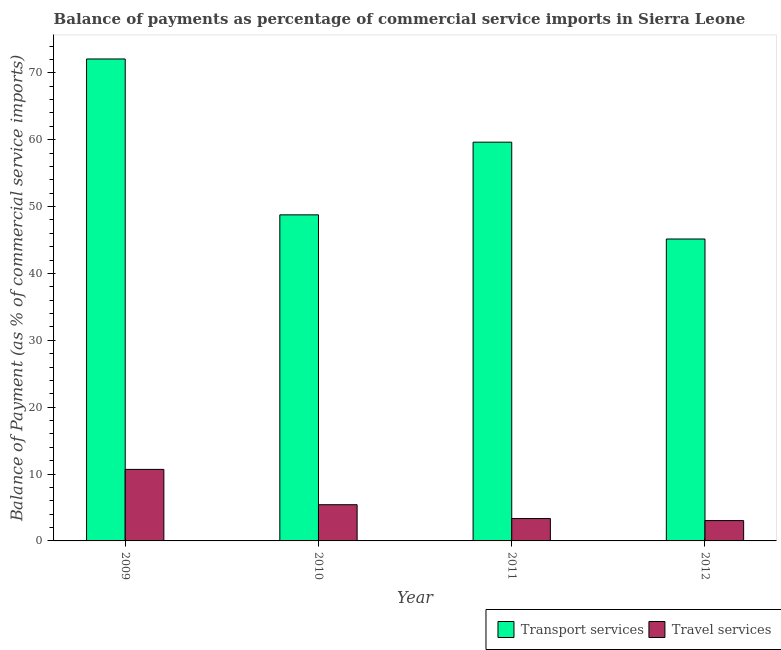How many groups of bars are there?
Ensure brevity in your answer.  4. Are the number of bars per tick equal to the number of legend labels?
Provide a succinct answer. Yes. How many bars are there on the 3rd tick from the left?
Make the answer very short. 2. How many bars are there on the 4th tick from the right?
Provide a short and direct response. 2. What is the label of the 4th group of bars from the left?
Offer a very short reply. 2012. In how many cases, is the number of bars for a given year not equal to the number of legend labels?
Make the answer very short. 0. What is the balance of payments of transport services in 2009?
Give a very brief answer. 72.08. Across all years, what is the maximum balance of payments of travel services?
Your answer should be compact. 10.7. Across all years, what is the minimum balance of payments of travel services?
Keep it short and to the point. 3.04. In which year was the balance of payments of travel services maximum?
Your answer should be very brief. 2009. What is the total balance of payments of travel services in the graph?
Give a very brief answer. 22.5. What is the difference between the balance of payments of travel services in 2010 and that in 2011?
Ensure brevity in your answer.  2.07. What is the difference between the balance of payments of transport services in 2011 and the balance of payments of travel services in 2009?
Give a very brief answer. -12.44. What is the average balance of payments of travel services per year?
Provide a short and direct response. 5.63. What is the ratio of the balance of payments of transport services in 2009 to that in 2012?
Your answer should be very brief. 1.6. What is the difference between the highest and the second highest balance of payments of transport services?
Make the answer very short. 12.44. What is the difference between the highest and the lowest balance of payments of travel services?
Offer a terse response. 7.66. In how many years, is the balance of payments of transport services greater than the average balance of payments of transport services taken over all years?
Your response must be concise. 2. What does the 2nd bar from the left in 2010 represents?
Provide a succinct answer. Travel services. What does the 1st bar from the right in 2011 represents?
Ensure brevity in your answer.  Travel services. How many bars are there?
Offer a very short reply. 8. Are all the bars in the graph horizontal?
Provide a short and direct response. No. What is the difference between two consecutive major ticks on the Y-axis?
Ensure brevity in your answer.  10. Does the graph contain any zero values?
Offer a terse response. No. Does the graph contain grids?
Make the answer very short. No. What is the title of the graph?
Provide a short and direct response. Balance of payments as percentage of commercial service imports in Sierra Leone. Does "Males" appear as one of the legend labels in the graph?
Your response must be concise. No. What is the label or title of the X-axis?
Make the answer very short. Year. What is the label or title of the Y-axis?
Make the answer very short. Balance of Payment (as % of commercial service imports). What is the Balance of Payment (as % of commercial service imports) in Transport services in 2009?
Your answer should be very brief. 72.08. What is the Balance of Payment (as % of commercial service imports) of Travel services in 2009?
Make the answer very short. 10.7. What is the Balance of Payment (as % of commercial service imports) of Transport services in 2010?
Your answer should be very brief. 48.77. What is the Balance of Payment (as % of commercial service imports) in Travel services in 2010?
Provide a succinct answer. 5.42. What is the Balance of Payment (as % of commercial service imports) of Transport services in 2011?
Offer a terse response. 59.64. What is the Balance of Payment (as % of commercial service imports) of Travel services in 2011?
Your answer should be compact. 3.35. What is the Balance of Payment (as % of commercial service imports) of Transport services in 2012?
Offer a very short reply. 45.15. What is the Balance of Payment (as % of commercial service imports) in Travel services in 2012?
Offer a very short reply. 3.04. Across all years, what is the maximum Balance of Payment (as % of commercial service imports) of Transport services?
Make the answer very short. 72.08. Across all years, what is the maximum Balance of Payment (as % of commercial service imports) of Travel services?
Provide a short and direct response. 10.7. Across all years, what is the minimum Balance of Payment (as % of commercial service imports) in Transport services?
Give a very brief answer. 45.15. Across all years, what is the minimum Balance of Payment (as % of commercial service imports) in Travel services?
Provide a succinct answer. 3.04. What is the total Balance of Payment (as % of commercial service imports) of Transport services in the graph?
Your answer should be compact. 225.64. What is the total Balance of Payment (as % of commercial service imports) of Travel services in the graph?
Your response must be concise. 22.5. What is the difference between the Balance of Payment (as % of commercial service imports) of Transport services in 2009 and that in 2010?
Offer a very short reply. 23.31. What is the difference between the Balance of Payment (as % of commercial service imports) in Travel services in 2009 and that in 2010?
Your answer should be very brief. 5.28. What is the difference between the Balance of Payment (as % of commercial service imports) of Transport services in 2009 and that in 2011?
Ensure brevity in your answer.  12.44. What is the difference between the Balance of Payment (as % of commercial service imports) in Travel services in 2009 and that in 2011?
Make the answer very short. 7.35. What is the difference between the Balance of Payment (as % of commercial service imports) of Transport services in 2009 and that in 2012?
Provide a succinct answer. 26.93. What is the difference between the Balance of Payment (as % of commercial service imports) in Travel services in 2009 and that in 2012?
Offer a very short reply. 7.66. What is the difference between the Balance of Payment (as % of commercial service imports) of Transport services in 2010 and that in 2011?
Keep it short and to the point. -10.87. What is the difference between the Balance of Payment (as % of commercial service imports) in Travel services in 2010 and that in 2011?
Make the answer very short. 2.07. What is the difference between the Balance of Payment (as % of commercial service imports) in Transport services in 2010 and that in 2012?
Your answer should be very brief. 3.61. What is the difference between the Balance of Payment (as % of commercial service imports) of Travel services in 2010 and that in 2012?
Give a very brief answer. 2.37. What is the difference between the Balance of Payment (as % of commercial service imports) in Transport services in 2011 and that in 2012?
Offer a very short reply. 14.48. What is the difference between the Balance of Payment (as % of commercial service imports) in Travel services in 2011 and that in 2012?
Offer a terse response. 0.31. What is the difference between the Balance of Payment (as % of commercial service imports) of Transport services in 2009 and the Balance of Payment (as % of commercial service imports) of Travel services in 2010?
Your response must be concise. 66.66. What is the difference between the Balance of Payment (as % of commercial service imports) in Transport services in 2009 and the Balance of Payment (as % of commercial service imports) in Travel services in 2011?
Give a very brief answer. 68.73. What is the difference between the Balance of Payment (as % of commercial service imports) in Transport services in 2009 and the Balance of Payment (as % of commercial service imports) in Travel services in 2012?
Provide a succinct answer. 69.04. What is the difference between the Balance of Payment (as % of commercial service imports) in Transport services in 2010 and the Balance of Payment (as % of commercial service imports) in Travel services in 2011?
Your response must be concise. 45.42. What is the difference between the Balance of Payment (as % of commercial service imports) in Transport services in 2010 and the Balance of Payment (as % of commercial service imports) in Travel services in 2012?
Your answer should be compact. 45.73. What is the difference between the Balance of Payment (as % of commercial service imports) of Transport services in 2011 and the Balance of Payment (as % of commercial service imports) of Travel services in 2012?
Offer a terse response. 56.59. What is the average Balance of Payment (as % of commercial service imports) of Transport services per year?
Ensure brevity in your answer.  56.41. What is the average Balance of Payment (as % of commercial service imports) in Travel services per year?
Keep it short and to the point. 5.63. In the year 2009, what is the difference between the Balance of Payment (as % of commercial service imports) in Transport services and Balance of Payment (as % of commercial service imports) in Travel services?
Give a very brief answer. 61.38. In the year 2010, what is the difference between the Balance of Payment (as % of commercial service imports) in Transport services and Balance of Payment (as % of commercial service imports) in Travel services?
Ensure brevity in your answer.  43.35. In the year 2011, what is the difference between the Balance of Payment (as % of commercial service imports) of Transport services and Balance of Payment (as % of commercial service imports) of Travel services?
Keep it short and to the point. 56.29. In the year 2012, what is the difference between the Balance of Payment (as % of commercial service imports) of Transport services and Balance of Payment (as % of commercial service imports) of Travel services?
Make the answer very short. 42.11. What is the ratio of the Balance of Payment (as % of commercial service imports) of Transport services in 2009 to that in 2010?
Keep it short and to the point. 1.48. What is the ratio of the Balance of Payment (as % of commercial service imports) in Travel services in 2009 to that in 2010?
Your answer should be very brief. 1.98. What is the ratio of the Balance of Payment (as % of commercial service imports) in Transport services in 2009 to that in 2011?
Ensure brevity in your answer.  1.21. What is the ratio of the Balance of Payment (as % of commercial service imports) in Travel services in 2009 to that in 2011?
Provide a short and direct response. 3.19. What is the ratio of the Balance of Payment (as % of commercial service imports) in Transport services in 2009 to that in 2012?
Offer a very short reply. 1.6. What is the ratio of the Balance of Payment (as % of commercial service imports) in Travel services in 2009 to that in 2012?
Offer a very short reply. 3.52. What is the ratio of the Balance of Payment (as % of commercial service imports) in Transport services in 2010 to that in 2011?
Provide a short and direct response. 0.82. What is the ratio of the Balance of Payment (as % of commercial service imports) of Travel services in 2010 to that in 2011?
Make the answer very short. 1.62. What is the ratio of the Balance of Payment (as % of commercial service imports) in Travel services in 2010 to that in 2012?
Your response must be concise. 1.78. What is the ratio of the Balance of Payment (as % of commercial service imports) in Transport services in 2011 to that in 2012?
Your answer should be very brief. 1.32. What is the ratio of the Balance of Payment (as % of commercial service imports) of Travel services in 2011 to that in 2012?
Offer a very short reply. 1.1. What is the difference between the highest and the second highest Balance of Payment (as % of commercial service imports) of Transport services?
Your answer should be compact. 12.44. What is the difference between the highest and the second highest Balance of Payment (as % of commercial service imports) in Travel services?
Give a very brief answer. 5.28. What is the difference between the highest and the lowest Balance of Payment (as % of commercial service imports) of Transport services?
Your response must be concise. 26.93. What is the difference between the highest and the lowest Balance of Payment (as % of commercial service imports) in Travel services?
Your answer should be very brief. 7.66. 